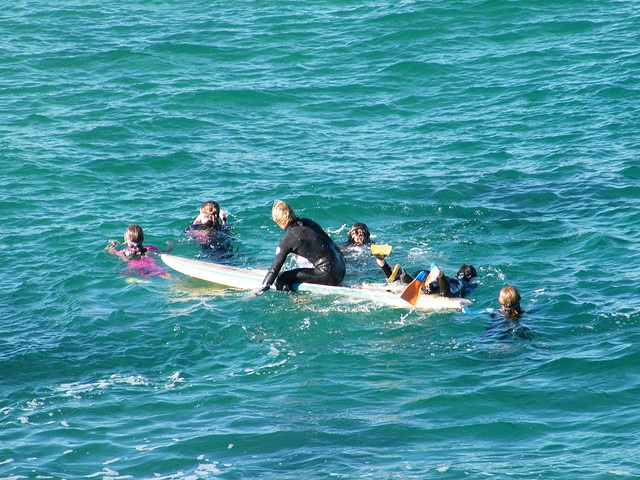Describe the objects in this image and their specific colors. I can see surfboard in teal, white, darkgray, and black tones, people in teal, black, gray, and navy tones, people in teal and black tones, people in teal, violet, darkgray, and gray tones, and people in teal, black, navy, brown, and ivory tones in this image. 